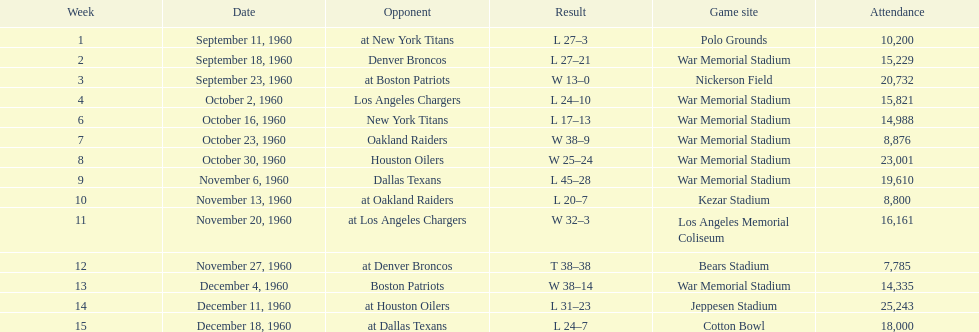What date was the first game at war memorial stadium? September 18, 1960. 